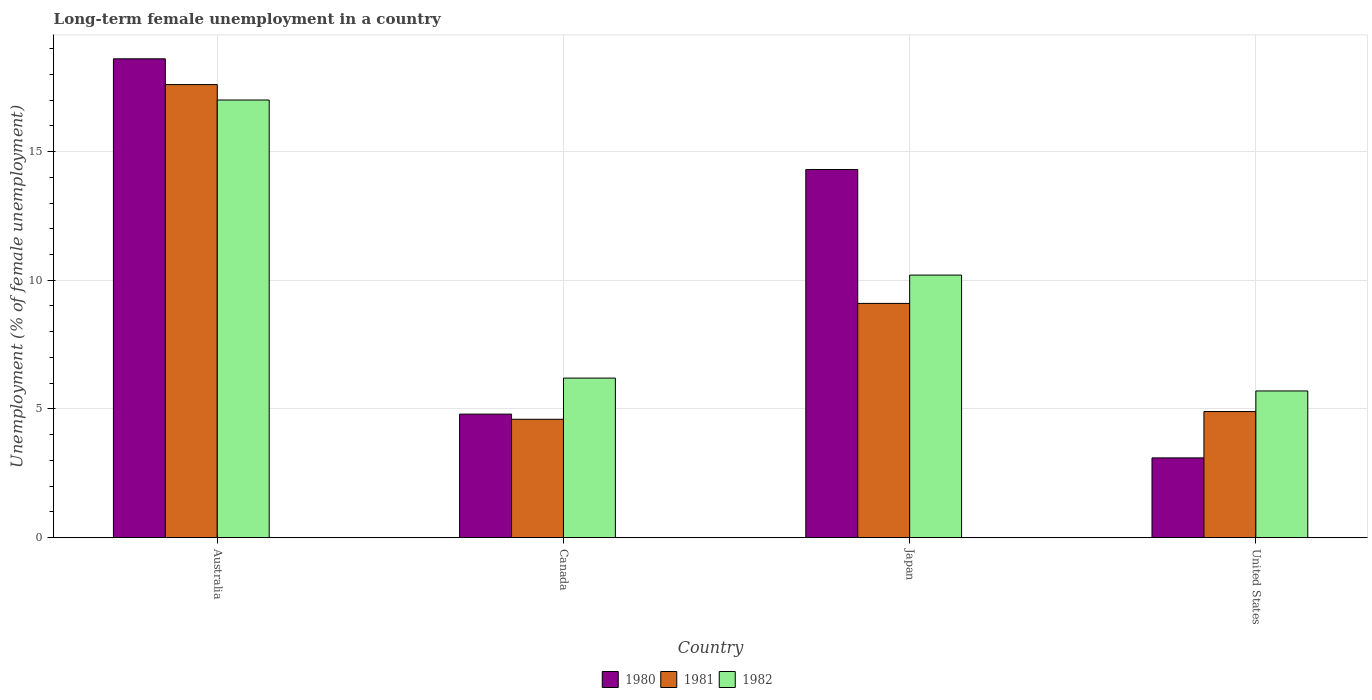How many different coloured bars are there?
Your answer should be very brief. 3. Are the number of bars on each tick of the X-axis equal?
Your response must be concise. Yes. How many bars are there on the 3rd tick from the left?
Your response must be concise. 3. What is the percentage of long-term unemployed female population in 1982 in United States?
Provide a succinct answer. 5.7. Across all countries, what is the maximum percentage of long-term unemployed female population in 1980?
Give a very brief answer. 18.6. Across all countries, what is the minimum percentage of long-term unemployed female population in 1982?
Offer a terse response. 5.7. In which country was the percentage of long-term unemployed female population in 1980 maximum?
Provide a succinct answer. Australia. What is the total percentage of long-term unemployed female population in 1981 in the graph?
Your response must be concise. 36.2. What is the difference between the percentage of long-term unemployed female population in 1980 in Canada and that in United States?
Your response must be concise. 1.7. What is the difference between the percentage of long-term unemployed female population in 1981 in Japan and the percentage of long-term unemployed female population in 1982 in Canada?
Give a very brief answer. 2.9. What is the average percentage of long-term unemployed female population in 1982 per country?
Ensure brevity in your answer.  9.77. What is the difference between the percentage of long-term unemployed female population of/in 1981 and percentage of long-term unemployed female population of/in 1982 in Australia?
Give a very brief answer. 0.6. In how many countries, is the percentage of long-term unemployed female population in 1981 greater than 14 %?
Keep it short and to the point. 1. What is the ratio of the percentage of long-term unemployed female population in 1980 in Australia to that in Japan?
Your response must be concise. 1.3. What is the difference between the highest and the second highest percentage of long-term unemployed female population in 1980?
Provide a short and direct response. 13.8. What is the difference between the highest and the lowest percentage of long-term unemployed female population in 1980?
Give a very brief answer. 15.5. How many countries are there in the graph?
Give a very brief answer. 4. What is the difference between two consecutive major ticks on the Y-axis?
Your response must be concise. 5. Are the values on the major ticks of Y-axis written in scientific E-notation?
Make the answer very short. No. Does the graph contain any zero values?
Your answer should be very brief. No. Where does the legend appear in the graph?
Ensure brevity in your answer.  Bottom center. How are the legend labels stacked?
Provide a short and direct response. Horizontal. What is the title of the graph?
Offer a very short reply. Long-term female unemployment in a country. Does "1989" appear as one of the legend labels in the graph?
Ensure brevity in your answer.  No. What is the label or title of the Y-axis?
Provide a succinct answer. Unemployment (% of female unemployment). What is the Unemployment (% of female unemployment) in 1980 in Australia?
Your answer should be compact. 18.6. What is the Unemployment (% of female unemployment) in 1981 in Australia?
Keep it short and to the point. 17.6. What is the Unemployment (% of female unemployment) of 1980 in Canada?
Your response must be concise. 4.8. What is the Unemployment (% of female unemployment) of 1981 in Canada?
Make the answer very short. 4.6. What is the Unemployment (% of female unemployment) in 1982 in Canada?
Give a very brief answer. 6.2. What is the Unemployment (% of female unemployment) of 1980 in Japan?
Your answer should be very brief. 14.3. What is the Unemployment (% of female unemployment) in 1981 in Japan?
Ensure brevity in your answer.  9.1. What is the Unemployment (% of female unemployment) of 1982 in Japan?
Provide a short and direct response. 10.2. What is the Unemployment (% of female unemployment) of 1980 in United States?
Keep it short and to the point. 3.1. What is the Unemployment (% of female unemployment) of 1981 in United States?
Offer a terse response. 4.9. What is the Unemployment (% of female unemployment) of 1982 in United States?
Ensure brevity in your answer.  5.7. Across all countries, what is the maximum Unemployment (% of female unemployment) of 1980?
Give a very brief answer. 18.6. Across all countries, what is the maximum Unemployment (% of female unemployment) in 1981?
Ensure brevity in your answer.  17.6. Across all countries, what is the minimum Unemployment (% of female unemployment) in 1980?
Provide a succinct answer. 3.1. Across all countries, what is the minimum Unemployment (% of female unemployment) of 1981?
Provide a succinct answer. 4.6. Across all countries, what is the minimum Unemployment (% of female unemployment) in 1982?
Offer a terse response. 5.7. What is the total Unemployment (% of female unemployment) in 1980 in the graph?
Offer a very short reply. 40.8. What is the total Unemployment (% of female unemployment) in 1981 in the graph?
Give a very brief answer. 36.2. What is the total Unemployment (% of female unemployment) in 1982 in the graph?
Ensure brevity in your answer.  39.1. What is the difference between the Unemployment (% of female unemployment) in 1980 in Australia and that in Canada?
Offer a terse response. 13.8. What is the difference between the Unemployment (% of female unemployment) in 1981 in Australia and that in Canada?
Your response must be concise. 13. What is the difference between the Unemployment (% of female unemployment) of 1982 in Australia and that in Canada?
Keep it short and to the point. 10.8. What is the difference between the Unemployment (% of female unemployment) in 1982 in Australia and that in Japan?
Provide a succinct answer. 6.8. What is the difference between the Unemployment (% of female unemployment) in 1981 in Australia and that in United States?
Your response must be concise. 12.7. What is the difference between the Unemployment (% of female unemployment) in 1980 in Canada and that in United States?
Ensure brevity in your answer.  1.7. What is the difference between the Unemployment (% of female unemployment) of 1981 in Canada and that in United States?
Ensure brevity in your answer.  -0.3. What is the difference between the Unemployment (% of female unemployment) in 1982 in Canada and that in United States?
Ensure brevity in your answer.  0.5. What is the difference between the Unemployment (% of female unemployment) of 1982 in Japan and that in United States?
Provide a short and direct response. 4.5. What is the difference between the Unemployment (% of female unemployment) in 1981 in Australia and the Unemployment (% of female unemployment) in 1982 in Canada?
Offer a very short reply. 11.4. What is the difference between the Unemployment (% of female unemployment) in 1981 in Australia and the Unemployment (% of female unemployment) in 1982 in Japan?
Your answer should be very brief. 7.4. What is the difference between the Unemployment (% of female unemployment) in 1980 in Australia and the Unemployment (% of female unemployment) in 1981 in United States?
Provide a short and direct response. 13.7. What is the difference between the Unemployment (% of female unemployment) of 1981 in Australia and the Unemployment (% of female unemployment) of 1982 in United States?
Provide a succinct answer. 11.9. What is the difference between the Unemployment (% of female unemployment) of 1980 in Canada and the Unemployment (% of female unemployment) of 1982 in Japan?
Your response must be concise. -5.4. What is the difference between the Unemployment (% of female unemployment) of 1981 in Canada and the Unemployment (% of female unemployment) of 1982 in Japan?
Offer a very short reply. -5.6. What is the difference between the Unemployment (% of female unemployment) in 1980 in Japan and the Unemployment (% of female unemployment) in 1981 in United States?
Your answer should be very brief. 9.4. What is the difference between the Unemployment (% of female unemployment) in 1980 in Japan and the Unemployment (% of female unemployment) in 1982 in United States?
Your response must be concise. 8.6. What is the difference between the Unemployment (% of female unemployment) in 1981 in Japan and the Unemployment (% of female unemployment) in 1982 in United States?
Make the answer very short. 3.4. What is the average Unemployment (% of female unemployment) of 1980 per country?
Provide a succinct answer. 10.2. What is the average Unemployment (% of female unemployment) in 1981 per country?
Ensure brevity in your answer.  9.05. What is the average Unemployment (% of female unemployment) in 1982 per country?
Your answer should be very brief. 9.78. What is the difference between the Unemployment (% of female unemployment) in 1980 and Unemployment (% of female unemployment) in 1981 in Australia?
Make the answer very short. 1. What is the difference between the Unemployment (% of female unemployment) of 1980 and Unemployment (% of female unemployment) of 1982 in Australia?
Make the answer very short. 1.6. What is the difference between the Unemployment (% of female unemployment) in 1980 and Unemployment (% of female unemployment) in 1982 in Canada?
Make the answer very short. -1.4. What is the difference between the Unemployment (% of female unemployment) in 1981 and Unemployment (% of female unemployment) in 1982 in Japan?
Offer a terse response. -1.1. What is the difference between the Unemployment (% of female unemployment) in 1981 and Unemployment (% of female unemployment) in 1982 in United States?
Provide a short and direct response. -0.8. What is the ratio of the Unemployment (% of female unemployment) in 1980 in Australia to that in Canada?
Your response must be concise. 3.88. What is the ratio of the Unemployment (% of female unemployment) of 1981 in Australia to that in Canada?
Your answer should be very brief. 3.83. What is the ratio of the Unemployment (% of female unemployment) in 1982 in Australia to that in Canada?
Your answer should be very brief. 2.74. What is the ratio of the Unemployment (% of female unemployment) of 1980 in Australia to that in Japan?
Keep it short and to the point. 1.3. What is the ratio of the Unemployment (% of female unemployment) in 1981 in Australia to that in Japan?
Ensure brevity in your answer.  1.93. What is the ratio of the Unemployment (% of female unemployment) of 1981 in Australia to that in United States?
Your answer should be very brief. 3.59. What is the ratio of the Unemployment (% of female unemployment) in 1982 in Australia to that in United States?
Give a very brief answer. 2.98. What is the ratio of the Unemployment (% of female unemployment) in 1980 in Canada to that in Japan?
Your response must be concise. 0.34. What is the ratio of the Unemployment (% of female unemployment) in 1981 in Canada to that in Japan?
Your answer should be very brief. 0.51. What is the ratio of the Unemployment (% of female unemployment) in 1982 in Canada to that in Japan?
Your response must be concise. 0.61. What is the ratio of the Unemployment (% of female unemployment) of 1980 in Canada to that in United States?
Offer a terse response. 1.55. What is the ratio of the Unemployment (% of female unemployment) of 1981 in Canada to that in United States?
Your response must be concise. 0.94. What is the ratio of the Unemployment (% of female unemployment) of 1982 in Canada to that in United States?
Make the answer very short. 1.09. What is the ratio of the Unemployment (% of female unemployment) of 1980 in Japan to that in United States?
Your response must be concise. 4.61. What is the ratio of the Unemployment (% of female unemployment) in 1981 in Japan to that in United States?
Your answer should be very brief. 1.86. What is the ratio of the Unemployment (% of female unemployment) of 1982 in Japan to that in United States?
Your answer should be very brief. 1.79. What is the difference between the highest and the second highest Unemployment (% of female unemployment) in 1980?
Offer a terse response. 4.3. What is the difference between the highest and the second highest Unemployment (% of female unemployment) of 1981?
Offer a terse response. 8.5. What is the difference between the highest and the second highest Unemployment (% of female unemployment) of 1982?
Your answer should be very brief. 6.8. What is the difference between the highest and the lowest Unemployment (% of female unemployment) in 1981?
Make the answer very short. 13. 